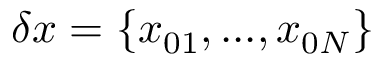<formula> <loc_0><loc_0><loc_500><loc_500>\delta x = \{ x _ { 0 1 } , \dots , x _ { 0 N } \}</formula> 